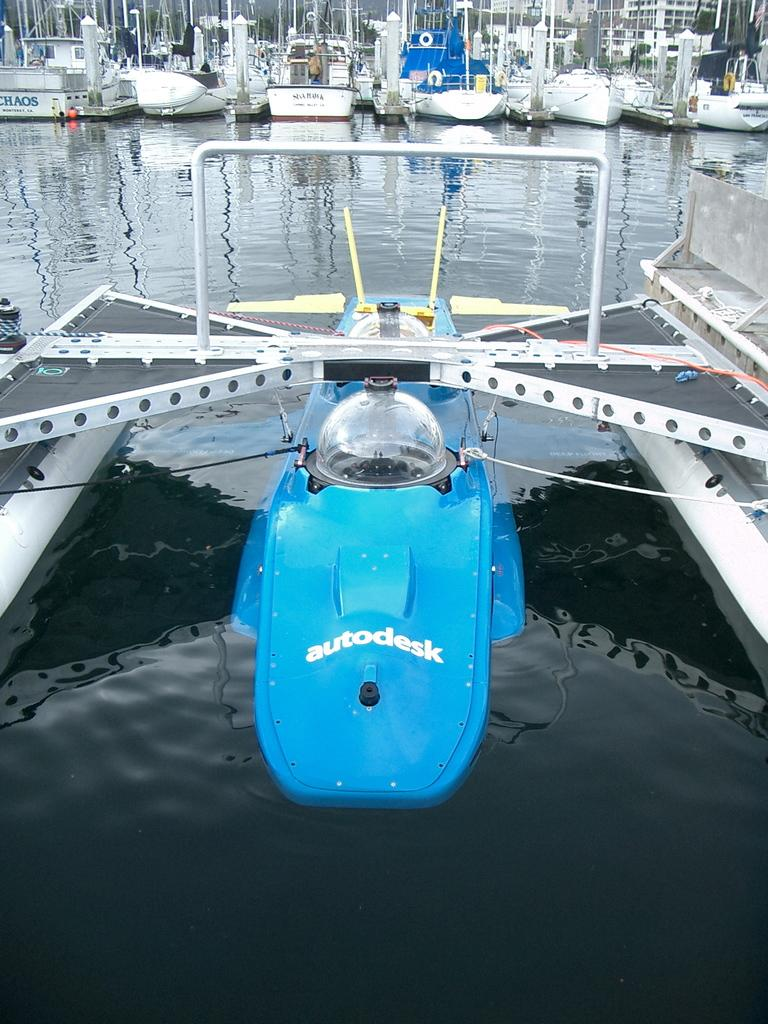<image>
Render a clear and concise summary of the photo. An autodesk boat that is half in the water and partially docked on the land. 